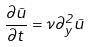Convert formula to latex. <formula><loc_0><loc_0><loc_500><loc_500>\frac { \partial \vec { u } } { \partial t } = \nu \partial _ { y } ^ { 2 } \vec { u }</formula> 